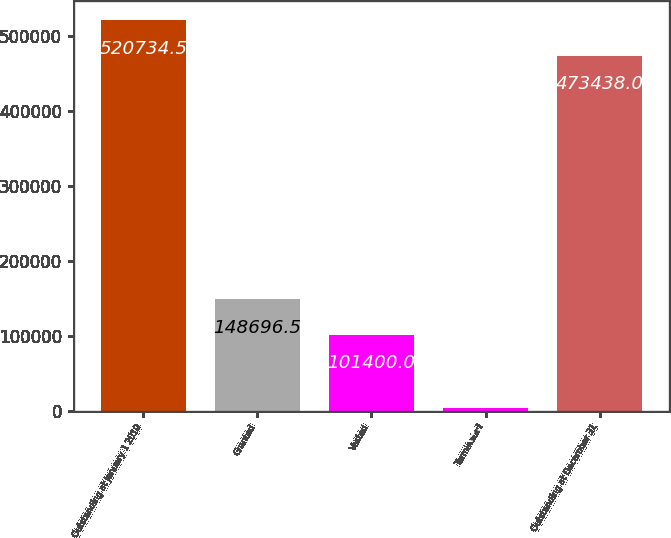<chart> <loc_0><loc_0><loc_500><loc_500><bar_chart><fcel>Outstanding at January 1 2010<fcel>Granted<fcel>Vested<fcel>Terminated<fcel>Outstanding at December 31<nl><fcel>520734<fcel>148696<fcel>101400<fcel>3278<fcel>473438<nl></chart> 